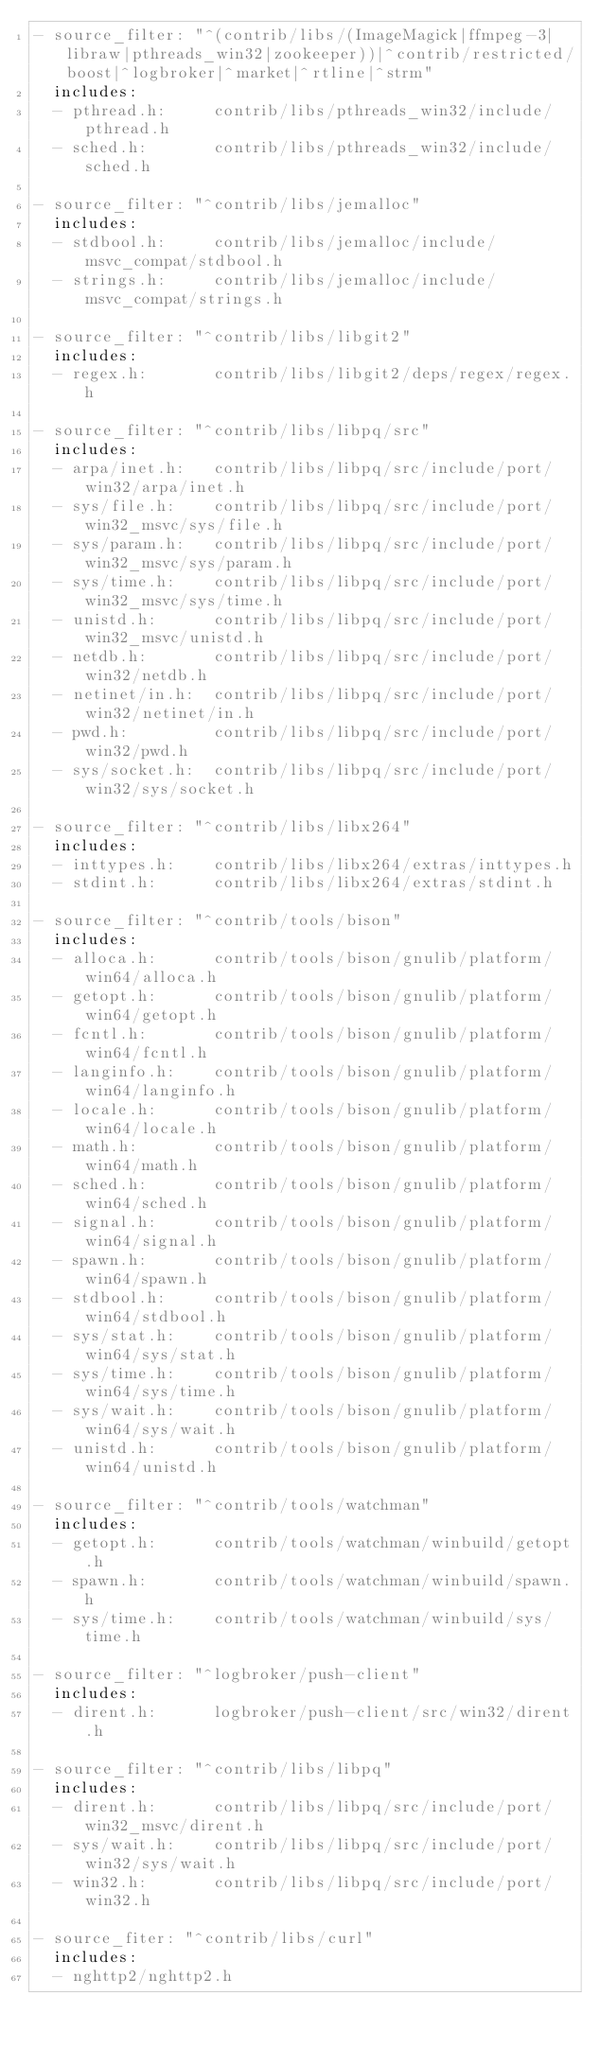<code> <loc_0><loc_0><loc_500><loc_500><_YAML_>- source_filter: "^(contrib/libs/(ImageMagick|ffmpeg-3|libraw|pthreads_win32|zookeeper))|^contrib/restricted/boost|^logbroker|^market|^rtline|^strm"
  includes:
  - pthread.h:     contrib/libs/pthreads_win32/include/pthread.h
  - sched.h:       contrib/libs/pthreads_win32/include/sched.h

- source_filter: "^contrib/libs/jemalloc"
  includes:
  - stdbool.h:     contrib/libs/jemalloc/include/msvc_compat/stdbool.h
  - strings.h:     contrib/libs/jemalloc/include/msvc_compat/strings.h

- source_filter: "^contrib/libs/libgit2"
  includes:
  - regex.h:       contrib/libs/libgit2/deps/regex/regex.h

- source_filter: "^contrib/libs/libpq/src"
  includes:
  - arpa/inet.h:   contrib/libs/libpq/src/include/port/win32/arpa/inet.h
  - sys/file.h:    contrib/libs/libpq/src/include/port/win32_msvc/sys/file.h
  - sys/param.h:   contrib/libs/libpq/src/include/port/win32_msvc/sys/param.h
  - sys/time.h:    contrib/libs/libpq/src/include/port/win32_msvc/sys/time.h
  - unistd.h:      contrib/libs/libpq/src/include/port/win32_msvc/unistd.h
  - netdb.h:       contrib/libs/libpq/src/include/port/win32/netdb.h
  - netinet/in.h:  contrib/libs/libpq/src/include/port/win32/netinet/in.h
  - pwd.h:         contrib/libs/libpq/src/include/port/win32/pwd.h
  - sys/socket.h:  contrib/libs/libpq/src/include/port/win32/sys/socket.h

- source_filter: "^contrib/libs/libx264"
  includes:
  - inttypes.h:    contrib/libs/libx264/extras/inttypes.h
  - stdint.h:      contrib/libs/libx264/extras/stdint.h

- source_filter: "^contrib/tools/bison"
  includes:
  - alloca.h:      contrib/tools/bison/gnulib/platform/win64/alloca.h
  - getopt.h:      contrib/tools/bison/gnulib/platform/win64/getopt.h
  - fcntl.h:       contrib/tools/bison/gnulib/platform/win64/fcntl.h
  - langinfo.h:    contrib/tools/bison/gnulib/platform/win64/langinfo.h
  - locale.h:      contrib/tools/bison/gnulib/platform/win64/locale.h
  - math.h:        contrib/tools/bison/gnulib/platform/win64/math.h
  - sched.h:       contrib/tools/bison/gnulib/platform/win64/sched.h
  - signal.h:      contrib/tools/bison/gnulib/platform/win64/signal.h
  - spawn.h:       contrib/tools/bison/gnulib/platform/win64/spawn.h
  - stdbool.h:     contrib/tools/bison/gnulib/platform/win64/stdbool.h
  - sys/stat.h:    contrib/tools/bison/gnulib/platform/win64/sys/stat.h
  - sys/time.h:    contrib/tools/bison/gnulib/platform/win64/sys/time.h
  - sys/wait.h:    contrib/tools/bison/gnulib/platform/win64/sys/wait.h
  - unistd.h:      contrib/tools/bison/gnulib/platform/win64/unistd.h

- source_filter: "^contrib/tools/watchman"
  includes:
  - getopt.h:      contrib/tools/watchman/winbuild/getopt.h
  - spawn.h:       contrib/tools/watchman/winbuild/spawn.h
  - sys/time.h:    contrib/tools/watchman/winbuild/sys/time.h

- source_filter: "^logbroker/push-client"
  includes:
  - dirent.h:      logbroker/push-client/src/win32/dirent.h

- source_filter: "^contrib/libs/libpq"
  includes:
  - dirent.h:      contrib/libs/libpq/src/include/port/win32_msvc/dirent.h
  - sys/wait.h:    contrib/libs/libpq/src/include/port/win32/sys/wait.h
  - win32.h:       contrib/libs/libpq/src/include/port/win32.h

- source_fiter: "^contrib/libs/curl"
  includes:
  - nghttp2/nghttp2.h
</code> 